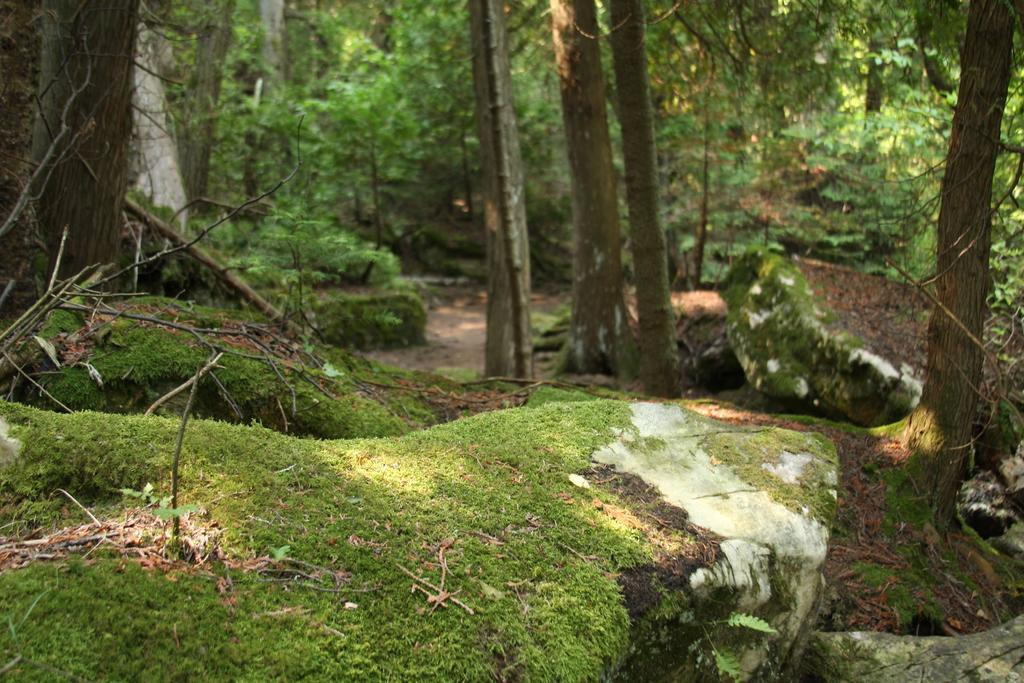What types of vegetation are present in the image? There are mosses and plants in the image. What other objects can be seen in the image? There are sticks visible in the image. What can be seen in the background of the image? There are trees in the background of the image. Can you see any horses running on the mountain in the image? There is no mountain or horses present in the image; it features mosses, plants, and sticks. 